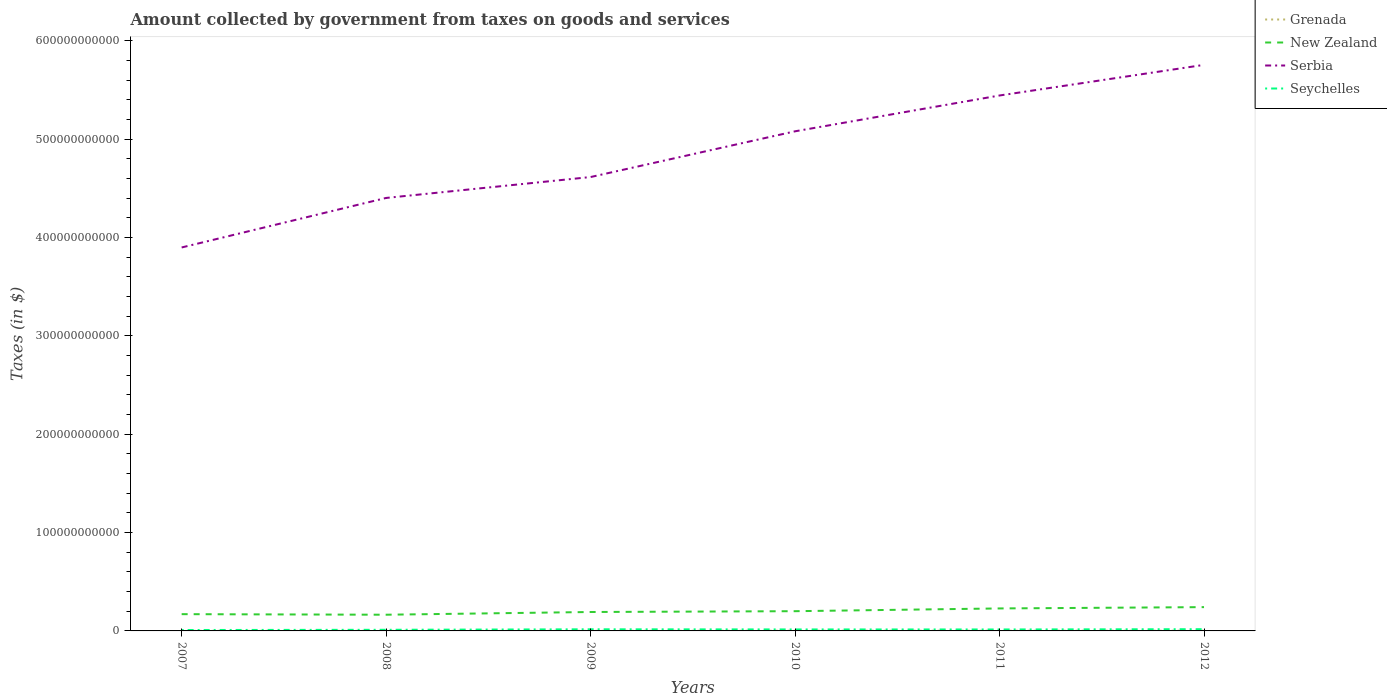How many different coloured lines are there?
Offer a very short reply. 4. Across all years, what is the maximum amount collected by government from taxes on goods and services in Seychelles?
Make the answer very short. 9.26e+08. In which year was the amount collected by government from taxes on goods and services in Grenada maximum?
Offer a terse response. 2007. What is the total amount collected by government from taxes on goods and services in Seychelles in the graph?
Provide a short and direct response. 2.78e+07. What is the difference between the highest and the second highest amount collected by government from taxes on goods and services in Seychelles?
Ensure brevity in your answer.  8.33e+08. What is the difference between the highest and the lowest amount collected by government from taxes on goods and services in Serbia?
Provide a short and direct response. 3. Is the amount collected by government from taxes on goods and services in Serbia strictly greater than the amount collected by government from taxes on goods and services in Grenada over the years?
Provide a short and direct response. No. What is the difference between two consecutive major ticks on the Y-axis?
Offer a terse response. 1.00e+11. Does the graph contain grids?
Offer a terse response. No. What is the title of the graph?
Offer a terse response. Amount collected by government from taxes on goods and services. What is the label or title of the X-axis?
Your answer should be very brief. Years. What is the label or title of the Y-axis?
Give a very brief answer. Taxes (in $). What is the Taxes (in $) in Grenada in 2007?
Keep it short and to the point. 7.13e+07. What is the Taxes (in $) in New Zealand in 2007?
Your answer should be compact. 1.70e+1. What is the Taxes (in $) in Serbia in 2007?
Keep it short and to the point. 3.90e+11. What is the Taxes (in $) of Seychelles in 2007?
Give a very brief answer. 9.26e+08. What is the Taxes (in $) of Grenada in 2008?
Your response must be concise. 7.87e+07. What is the Taxes (in $) in New Zealand in 2008?
Your response must be concise. 1.65e+1. What is the Taxes (in $) of Serbia in 2008?
Provide a short and direct response. 4.40e+11. What is the Taxes (in $) in Seychelles in 2008?
Provide a short and direct response. 1.15e+09. What is the Taxes (in $) of Grenada in 2009?
Provide a succinct answer. 7.60e+07. What is the Taxes (in $) in New Zealand in 2009?
Offer a terse response. 1.92e+1. What is the Taxes (in $) in Serbia in 2009?
Provide a short and direct response. 4.62e+11. What is the Taxes (in $) in Seychelles in 2009?
Your answer should be very brief. 1.66e+09. What is the Taxes (in $) in Grenada in 2010?
Your answer should be compact. 1.78e+08. What is the Taxes (in $) in New Zealand in 2010?
Your answer should be very brief. 2.01e+1. What is the Taxes (in $) of Serbia in 2010?
Provide a short and direct response. 5.08e+11. What is the Taxes (in $) in Seychelles in 2010?
Your answer should be very brief. 1.51e+09. What is the Taxes (in $) of Grenada in 2011?
Provide a succinct answer. 1.90e+08. What is the Taxes (in $) in New Zealand in 2011?
Keep it short and to the point. 2.29e+1. What is the Taxes (in $) of Serbia in 2011?
Make the answer very short. 5.45e+11. What is the Taxes (in $) in Seychelles in 2011?
Offer a very short reply. 1.48e+09. What is the Taxes (in $) in Grenada in 2012?
Make the answer very short. 1.90e+08. What is the Taxes (in $) in New Zealand in 2012?
Your response must be concise. 2.42e+1. What is the Taxes (in $) in Serbia in 2012?
Provide a succinct answer. 5.76e+11. What is the Taxes (in $) of Seychelles in 2012?
Offer a terse response. 1.76e+09. Across all years, what is the maximum Taxes (in $) of Grenada?
Your response must be concise. 1.90e+08. Across all years, what is the maximum Taxes (in $) in New Zealand?
Ensure brevity in your answer.  2.42e+1. Across all years, what is the maximum Taxes (in $) of Serbia?
Provide a short and direct response. 5.76e+11. Across all years, what is the maximum Taxes (in $) in Seychelles?
Offer a terse response. 1.76e+09. Across all years, what is the minimum Taxes (in $) of Grenada?
Make the answer very short. 7.13e+07. Across all years, what is the minimum Taxes (in $) in New Zealand?
Offer a very short reply. 1.65e+1. Across all years, what is the minimum Taxes (in $) in Serbia?
Offer a terse response. 3.90e+11. Across all years, what is the minimum Taxes (in $) of Seychelles?
Offer a very short reply. 9.26e+08. What is the total Taxes (in $) in Grenada in the graph?
Your answer should be very brief. 7.84e+08. What is the total Taxes (in $) of New Zealand in the graph?
Your response must be concise. 1.20e+11. What is the total Taxes (in $) in Serbia in the graph?
Make the answer very short. 2.92e+12. What is the total Taxes (in $) of Seychelles in the graph?
Your answer should be compact. 8.48e+09. What is the difference between the Taxes (in $) of Grenada in 2007 and that in 2008?
Offer a very short reply. -7.40e+06. What is the difference between the Taxes (in $) in New Zealand in 2007 and that in 2008?
Your answer should be very brief. 5.72e+08. What is the difference between the Taxes (in $) in Serbia in 2007 and that in 2008?
Make the answer very short. -5.04e+1. What is the difference between the Taxes (in $) in Seychelles in 2007 and that in 2008?
Ensure brevity in your answer.  -2.20e+08. What is the difference between the Taxes (in $) of Grenada in 2007 and that in 2009?
Offer a terse response. -4.70e+06. What is the difference between the Taxes (in $) of New Zealand in 2007 and that in 2009?
Your answer should be compact. -2.20e+09. What is the difference between the Taxes (in $) of Serbia in 2007 and that in 2009?
Keep it short and to the point. -7.16e+1. What is the difference between the Taxes (in $) in Seychelles in 2007 and that in 2009?
Offer a very short reply. -7.33e+08. What is the difference between the Taxes (in $) in Grenada in 2007 and that in 2010?
Provide a succinct answer. -1.07e+08. What is the difference between the Taxes (in $) of New Zealand in 2007 and that in 2010?
Give a very brief answer. -3.02e+09. What is the difference between the Taxes (in $) of Serbia in 2007 and that in 2010?
Make the answer very short. -1.18e+11. What is the difference between the Taxes (in $) of Seychelles in 2007 and that in 2010?
Make the answer very short. -5.84e+08. What is the difference between the Taxes (in $) of Grenada in 2007 and that in 2011?
Provide a short and direct response. -1.18e+08. What is the difference between the Taxes (in $) of New Zealand in 2007 and that in 2011?
Your answer should be compact. -5.82e+09. What is the difference between the Taxes (in $) in Serbia in 2007 and that in 2011?
Your answer should be compact. -1.55e+11. What is the difference between the Taxes (in $) in Seychelles in 2007 and that in 2011?
Your response must be concise. -5.56e+08. What is the difference between the Taxes (in $) of Grenada in 2007 and that in 2012?
Offer a very short reply. -1.18e+08. What is the difference between the Taxes (in $) of New Zealand in 2007 and that in 2012?
Make the answer very short. -7.15e+09. What is the difference between the Taxes (in $) of Serbia in 2007 and that in 2012?
Your answer should be compact. -1.86e+11. What is the difference between the Taxes (in $) of Seychelles in 2007 and that in 2012?
Provide a succinct answer. -8.33e+08. What is the difference between the Taxes (in $) in Grenada in 2008 and that in 2009?
Make the answer very short. 2.70e+06. What is the difference between the Taxes (in $) of New Zealand in 2008 and that in 2009?
Make the answer very short. -2.77e+09. What is the difference between the Taxes (in $) in Serbia in 2008 and that in 2009?
Keep it short and to the point. -2.13e+1. What is the difference between the Taxes (in $) of Seychelles in 2008 and that in 2009?
Offer a terse response. -5.13e+08. What is the difference between the Taxes (in $) of Grenada in 2008 and that in 2010?
Your answer should be very brief. -9.95e+07. What is the difference between the Taxes (in $) in New Zealand in 2008 and that in 2010?
Your response must be concise. -3.60e+09. What is the difference between the Taxes (in $) of Serbia in 2008 and that in 2010?
Your answer should be very brief. -6.78e+1. What is the difference between the Taxes (in $) of Seychelles in 2008 and that in 2010?
Give a very brief answer. -3.64e+08. What is the difference between the Taxes (in $) in Grenada in 2008 and that in 2011?
Your answer should be compact. -1.11e+08. What is the difference between the Taxes (in $) in New Zealand in 2008 and that in 2011?
Your answer should be very brief. -6.40e+09. What is the difference between the Taxes (in $) in Serbia in 2008 and that in 2011?
Your answer should be very brief. -1.04e+11. What is the difference between the Taxes (in $) in Seychelles in 2008 and that in 2011?
Offer a very short reply. -3.36e+08. What is the difference between the Taxes (in $) of Grenada in 2008 and that in 2012?
Your response must be concise. -1.11e+08. What is the difference between the Taxes (in $) in New Zealand in 2008 and that in 2012?
Offer a very short reply. -7.72e+09. What is the difference between the Taxes (in $) of Serbia in 2008 and that in 2012?
Ensure brevity in your answer.  -1.35e+11. What is the difference between the Taxes (in $) of Seychelles in 2008 and that in 2012?
Provide a short and direct response. -6.13e+08. What is the difference between the Taxes (in $) of Grenada in 2009 and that in 2010?
Offer a very short reply. -1.02e+08. What is the difference between the Taxes (in $) in New Zealand in 2009 and that in 2010?
Make the answer very short. -8.25e+08. What is the difference between the Taxes (in $) in Serbia in 2009 and that in 2010?
Provide a short and direct response. -4.65e+1. What is the difference between the Taxes (in $) of Seychelles in 2009 and that in 2010?
Your answer should be very brief. 1.49e+08. What is the difference between the Taxes (in $) in Grenada in 2009 and that in 2011?
Offer a terse response. -1.14e+08. What is the difference between the Taxes (in $) in New Zealand in 2009 and that in 2011?
Your answer should be compact. -3.63e+09. What is the difference between the Taxes (in $) of Serbia in 2009 and that in 2011?
Offer a very short reply. -8.29e+1. What is the difference between the Taxes (in $) of Seychelles in 2009 and that in 2011?
Ensure brevity in your answer.  1.77e+08. What is the difference between the Taxes (in $) in Grenada in 2009 and that in 2012?
Provide a short and direct response. -1.14e+08. What is the difference between the Taxes (in $) in New Zealand in 2009 and that in 2012?
Make the answer very short. -4.95e+09. What is the difference between the Taxes (in $) of Serbia in 2009 and that in 2012?
Ensure brevity in your answer.  -1.14e+11. What is the difference between the Taxes (in $) in Seychelles in 2009 and that in 2012?
Offer a terse response. -1.00e+08. What is the difference between the Taxes (in $) of Grenada in 2010 and that in 2011?
Give a very brief answer. -1.16e+07. What is the difference between the Taxes (in $) in New Zealand in 2010 and that in 2011?
Your answer should be very brief. -2.80e+09. What is the difference between the Taxes (in $) in Serbia in 2010 and that in 2011?
Give a very brief answer. -3.64e+1. What is the difference between the Taxes (in $) of Seychelles in 2010 and that in 2011?
Provide a short and direct response. 2.78e+07. What is the difference between the Taxes (in $) in Grenada in 2010 and that in 2012?
Your answer should be compact. -1.13e+07. What is the difference between the Taxes (in $) of New Zealand in 2010 and that in 2012?
Your answer should be very brief. -4.13e+09. What is the difference between the Taxes (in $) of Serbia in 2010 and that in 2012?
Make the answer very short. -6.76e+1. What is the difference between the Taxes (in $) of Seychelles in 2010 and that in 2012?
Offer a terse response. -2.49e+08. What is the difference between the Taxes (in $) in New Zealand in 2011 and that in 2012?
Offer a terse response. -1.33e+09. What is the difference between the Taxes (in $) of Serbia in 2011 and that in 2012?
Your answer should be very brief. -3.11e+1. What is the difference between the Taxes (in $) in Seychelles in 2011 and that in 2012?
Keep it short and to the point. -2.77e+08. What is the difference between the Taxes (in $) of Grenada in 2007 and the Taxes (in $) of New Zealand in 2008?
Provide a succinct answer. -1.64e+1. What is the difference between the Taxes (in $) in Grenada in 2007 and the Taxes (in $) in Serbia in 2008?
Your answer should be compact. -4.40e+11. What is the difference between the Taxes (in $) in Grenada in 2007 and the Taxes (in $) in Seychelles in 2008?
Provide a short and direct response. -1.08e+09. What is the difference between the Taxes (in $) in New Zealand in 2007 and the Taxes (in $) in Serbia in 2008?
Offer a very short reply. -4.23e+11. What is the difference between the Taxes (in $) of New Zealand in 2007 and the Taxes (in $) of Seychelles in 2008?
Provide a succinct answer. 1.59e+1. What is the difference between the Taxes (in $) in Serbia in 2007 and the Taxes (in $) in Seychelles in 2008?
Offer a terse response. 3.89e+11. What is the difference between the Taxes (in $) of Grenada in 2007 and the Taxes (in $) of New Zealand in 2009?
Ensure brevity in your answer.  -1.92e+1. What is the difference between the Taxes (in $) in Grenada in 2007 and the Taxes (in $) in Serbia in 2009?
Your answer should be compact. -4.62e+11. What is the difference between the Taxes (in $) of Grenada in 2007 and the Taxes (in $) of Seychelles in 2009?
Give a very brief answer. -1.59e+09. What is the difference between the Taxes (in $) in New Zealand in 2007 and the Taxes (in $) in Serbia in 2009?
Give a very brief answer. -4.45e+11. What is the difference between the Taxes (in $) in New Zealand in 2007 and the Taxes (in $) in Seychelles in 2009?
Provide a succinct answer. 1.54e+1. What is the difference between the Taxes (in $) in Serbia in 2007 and the Taxes (in $) in Seychelles in 2009?
Your answer should be very brief. 3.88e+11. What is the difference between the Taxes (in $) in Grenada in 2007 and the Taxes (in $) in New Zealand in 2010?
Offer a very short reply. -2.00e+1. What is the difference between the Taxes (in $) of Grenada in 2007 and the Taxes (in $) of Serbia in 2010?
Make the answer very short. -5.08e+11. What is the difference between the Taxes (in $) of Grenada in 2007 and the Taxes (in $) of Seychelles in 2010?
Offer a very short reply. -1.44e+09. What is the difference between the Taxes (in $) of New Zealand in 2007 and the Taxes (in $) of Serbia in 2010?
Your answer should be compact. -4.91e+11. What is the difference between the Taxes (in $) of New Zealand in 2007 and the Taxes (in $) of Seychelles in 2010?
Your answer should be very brief. 1.55e+1. What is the difference between the Taxes (in $) of Serbia in 2007 and the Taxes (in $) of Seychelles in 2010?
Ensure brevity in your answer.  3.88e+11. What is the difference between the Taxes (in $) in Grenada in 2007 and the Taxes (in $) in New Zealand in 2011?
Make the answer very short. -2.28e+1. What is the difference between the Taxes (in $) of Grenada in 2007 and the Taxes (in $) of Serbia in 2011?
Give a very brief answer. -5.44e+11. What is the difference between the Taxes (in $) in Grenada in 2007 and the Taxes (in $) in Seychelles in 2011?
Your answer should be compact. -1.41e+09. What is the difference between the Taxes (in $) of New Zealand in 2007 and the Taxes (in $) of Serbia in 2011?
Your answer should be very brief. -5.27e+11. What is the difference between the Taxes (in $) of New Zealand in 2007 and the Taxes (in $) of Seychelles in 2011?
Ensure brevity in your answer.  1.56e+1. What is the difference between the Taxes (in $) of Serbia in 2007 and the Taxes (in $) of Seychelles in 2011?
Keep it short and to the point. 3.88e+11. What is the difference between the Taxes (in $) of Grenada in 2007 and the Taxes (in $) of New Zealand in 2012?
Provide a short and direct response. -2.41e+1. What is the difference between the Taxes (in $) of Grenada in 2007 and the Taxes (in $) of Serbia in 2012?
Offer a terse response. -5.76e+11. What is the difference between the Taxes (in $) of Grenada in 2007 and the Taxes (in $) of Seychelles in 2012?
Offer a very short reply. -1.69e+09. What is the difference between the Taxes (in $) in New Zealand in 2007 and the Taxes (in $) in Serbia in 2012?
Ensure brevity in your answer.  -5.59e+11. What is the difference between the Taxes (in $) of New Zealand in 2007 and the Taxes (in $) of Seychelles in 2012?
Your answer should be very brief. 1.53e+1. What is the difference between the Taxes (in $) in Serbia in 2007 and the Taxes (in $) in Seychelles in 2012?
Your answer should be compact. 3.88e+11. What is the difference between the Taxes (in $) in Grenada in 2008 and the Taxes (in $) in New Zealand in 2009?
Offer a very short reply. -1.92e+1. What is the difference between the Taxes (in $) of Grenada in 2008 and the Taxes (in $) of Serbia in 2009?
Your answer should be compact. -4.62e+11. What is the difference between the Taxes (in $) of Grenada in 2008 and the Taxes (in $) of Seychelles in 2009?
Keep it short and to the point. -1.58e+09. What is the difference between the Taxes (in $) in New Zealand in 2008 and the Taxes (in $) in Serbia in 2009?
Offer a terse response. -4.45e+11. What is the difference between the Taxes (in $) in New Zealand in 2008 and the Taxes (in $) in Seychelles in 2009?
Your answer should be compact. 1.48e+1. What is the difference between the Taxes (in $) of Serbia in 2008 and the Taxes (in $) of Seychelles in 2009?
Your response must be concise. 4.39e+11. What is the difference between the Taxes (in $) of Grenada in 2008 and the Taxes (in $) of New Zealand in 2010?
Your answer should be very brief. -2.00e+1. What is the difference between the Taxes (in $) in Grenada in 2008 and the Taxes (in $) in Serbia in 2010?
Give a very brief answer. -5.08e+11. What is the difference between the Taxes (in $) in Grenada in 2008 and the Taxes (in $) in Seychelles in 2010?
Give a very brief answer. -1.43e+09. What is the difference between the Taxes (in $) of New Zealand in 2008 and the Taxes (in $) of Serbia in 2010?
Provide a succinct answer. -4.92e+11. What is the difference between the Taxes (in $) of New Zealand in 2008 and the Taxes (in $) of Seychelles in 2010?
Your response must be concise. 1.50e+1. What is the difference between the Taxes (in $) of Serbia in 2008 and the Taxes (in $) of Seychelles in 2010?
Offer a terse response. 4.39e+11. What is the difference between the Taxes (in $) in Grenada in 2008 and the Taxes (in $) in New Zealand in 2011?
Your answer should be compact. -2.28e+1. What is the difference between the Taxes (in $) of Grenada in 2008 and the Taxes (in $) of Serbia in 2011?
Offer a terse response. -5.44e+11. What is the difference between the Taxes (in $) of Grenada in 2008 and the Taxes (in $) of Seychelles in 2011?
Ensure brevity in your answer.  -1.40e+09. What is the difference between the Taxes (in $) in New Zealand in 2008 and the Taxes (in $) in Serbia in 2011?
Offer a very short reply. -5.28e+11. What is the difference between the Taxes (in $) in New Zealand in 2008 and the Taxes (in $) in Seychelles in 2011?
Keep it short and to the point. 1.50e+1. What is the difference between the Taxes (in $) of Serbia in 2008 and the Taxes (in $) of Seychelles in 2011?
Keep it short and to the point. 4.39e+11. What is the difference between the Taxes (in $) of Grenada in 2008 and the Taxes (in $) of New Zealand in 2012?
Offer a terse response. -2.41e+1. What is the difference between the Taxes (in $) of Grenada in 2008 and the Taxes (in $) of Serbia in 2012?
Provide a succinct answer. -5.76e+11. What is the difference between the Taxes (in $) of Grenada in 2008 and the Taxes (in $) of Seychelles in 2012?
Offer a very short reply. -1.68e+09. What is the difference between the Taxes (in $) of New Zealand in 2008 and the Taxes (in $) of Serbia in 2012?
Provide a short and direct response. -5.59e+11. What is the difference between the Taxes (in $) in New Zealand in 2008 and the Taxes (in $) in Seychelles in 2012?
Offer a terse response. 1.47e+1. What is the difference between the Taxes (in $) in Serbia in 2008 and the Taxes (in $) in Seychelles in 2012?
Offer a very short reply. 4.39e+11. What is the difference between the Taxes (in $) in Grenada in 2009 and the Taxes (in $) in New Zealand in 2010?
Ensure brevity in your answer.  -2.00e+1. What is the difference between the Taxes (in $) of Grenada in 2009 and the Taxes (in $) of Serbia in 2010?
Provide a succinct answer. -5.08e+11. What is the difference between the Taxes (in $) in Grenada in 2009 and the Taxes (in $) in Seychelles in 2010?
Provide a succinct answer. -1.43e+09. What is the difference between the Taxes (in $) of New Zealand in 2009 and the Taxes (in $) of Serbia in 2010?
Ensure brevity in your answer.  -4.89e+11. What is the difference between the Taxes (in $) in New Zealand in 2009 and the Taxes (in $) in Seychelles in 2010?
Make the answer very short. 1.77e+1. What is the difference between the Taxes (in $) in Serbia in 2009 and the Taxes (in $) in Seychelles in 2010?
Your answer should be compact. 4.60e+11. What is the difference between the Taxes (in $) in Grenada in 2009 and the Taxes (in $) in New Zealand in 2011?
Your response must be concise. -2.28e+1. What is the difference between the Taxes (in $) in Grenada in 2009 and the Taxes (in $) in Serbia in 2011?
Make the answer very short. -5.44e+11. What is the difference between the Taxes (in $) in Grenada in 2009 and the Taxes (in $) in Seychelles in 2011?
Provide a short and direct response. -1.41e+09. What is the difference between the Taxes (in $) of New Zealand in 2009 and the Taxes (in $) of Serbia in 2011?
Your answer should be very brief. -5.25e+11. What is the difference between the Taxes (in $) of New Zealand in 2009 and the Taxes (in $) of Seychelles in 2011?
Your answer should be compact. 1.78e+1. What is the difference between the Taxes (in $) of Serbia in 2009 and the Taxes (in $) of Seychelles in 2011?
Provide a short and direct response. 4.60e+11. What is the difference between the Taxes (in $) of Grenada in 2009 and the Taxes (in $) of New Zealand in 2012?
Ensure brevity in your answer.  -2.41e+1. What is the difference between the Taxes (in $) of Grenada in 2009 and the Taxes (in $) of Serbia in 2012?
Ensure brevity in your answer.  -5.76e+11. What is the difference between the Taxes (in $) in Grenada in 2009 and the Taxes (in $) in Seychelles in 2012?
Offer a terse response. -1.68e+09. What is the difference between the Taxes (in $) in New Zealand in 2009 and the Taxes (in $) in Serbia in 2012?
Your answer should be very brief. -5.56e+11. What is the difference between the Taxes (in $) of New Zealand in 2009 and the Taxes (in $) of Seychelles in 2012?
Give a very brief answer. 1.75e+1. What is the difference between the Taxes (in $) of Serbia in 2009 and the Taxes (in $) of Seychelles in 2012?
Provide a short and direct response. 4.60e+11. What is the difference between the Taxes (in $) of Grenada in 2010 and the Taxes (in $) of New Zealand in 2011?
Keep it short and to the point. -2.27e+1. What is the difference between the Taxes (in $) in Grenada in 2010 and the Taxes (in $) in Serbia in 2011?
Your answer should be compact. -5.44e+11. What is the difference between the Taxes (in $) in Grenada in 2010 and the Taxes (in $) in Seychelles in 2011?
Offer a terse response. -1.30e+09. What is the difference between the Taxes (in $) in New Zealand in 2010 and the Taxes (in $) in Serbia in 2011?
Your answer should be compact. -5.24e+11. What is the difference between the Taxes (in $) in New Zealand in 2010 and the Taxes (in $) in Seychelles in 2011?
Your answer should be compact. 1.86e+1. What is the difference between the Taxes (in $) in Serbia in 2010 and the Taxes (in $) in Seychelles in 2011?
Provide a short and direct response. 5.07e+11. What is the difference between the Taxes (in $) in Grenada in 2010 and the Taxes (in $) in New Zealand in 2012?
Offer a very short reply. -2.40e+1. What is the difference between the Taxes (in $) of Grenada in 2010 and the Taxes (in $) of Serbia in 2012?
Provide a succinct answer. -5.75e+11. What is the difference between the Taxes (in $) of Grenada in 2010 and the Taxes (in $) of Seychelles in 2012?
Your response must be concise. -1.58e+09. What is the difference between the Taxes (in $) of New Zealand in 2010 and the Taxes (in $) of Serbia in 2012?
Give a very brief answer. -5.56e+11. What is the difference between the Taxes (in $) of New Zealand in 2010 and the Taxes (in $) of Seychelles in 2012?
Offer a very short reply. 1.83e+1. What is the difference between the Taxes (in $) in Serbia in 2010 and the Taxes (in $) in Seychelles in 2012?
Your answer should be compact. 5.06e+11. What is the difference between the Taxes (in $) of Grenada in 2011 and the Taxes (in $) of New Zealand in 2012?
Your answer should be compact. -2.40e+1. What is the difference between the Taxes (in $) of Grenada in 2011 and the Taxes (in $) of Serbia in 2012?
Keep it short and to the point. -5.75e+11. What is the difference between the Taxes (in $) of Grenada in 2011 and the Taxes (in $) of Seychelles in 2012?
Provide a succinct answer. -1.57e+09. What is the difference between the Taxes (in $) in New Zealand in 2011 and the Taxes (in $) in Serbia in 2012?
Ensure brevity in your answer.  -5.53e+11. What is the difference between the Taxes (in $) in New Zealand in 2011 and the Taxes (in $) in Seychelles in 2012?
Provide a succinct answer. 2.11e+1. What is the difference between the Taxes (in $) in Serbia in 2011 and the Taxes (in $) in Seychelles in 2012?
Make the answer very short. 5.43e+11. What is the average Taxes (in $) in Grenada per year?
Offer a very short reply. 1.31e+08. What is the average Taxes (in $) in New Zealand per year?
Your response must be concise. 2.00e+1. What is the average Taxes (in $) of Serbia per year?
Offer a terse response. 4.87e+11. What is the average Taxes (in $) of Seychelles per year?
Your response must be concise. 1.41e+09. In the year 2007, what is the difference between the Taxes (in $) of Grenada and Taxes (in $) of New Zealand?
Keep it short and to the point. -1.70e+1. In the year 2007, what is the difference between the Taxes (in $) of Grenada and Taxes (in $) of Serbia?
Provide a succinct answer. -3.90e+11. In the year 2007, what is the difference between the Taxes (in $) of Grenada and Taxes (in $) of Seychelles?
Offer a very short reply. -8.55e+08. In the year 2007, what is the difference between the Taxes (in $) in New Zealand and Taxes (in $) in Serbia?
Keep it short and to the point. -3.73e+11. In the year 2007, what is the difference between the Taxes (in $) in New Zealand and Taxes (in $) in Seychelles?
Make the answer very short. 1.61e+1. In the year 2007, what is the difference between the Taxes (in $) in Serbia and Taxes (in $) in Seychelles?
Ensure brevity in your answer.  3.89e+11. In the year 2008, what is the difference between the Taxes (in $) of Grenada and Taxes (in $) of New Zealand?
Offer a very short reply. -1.64e+1. In the year 2008, what is the difference between the Taxes (in $) in Grenada and Taxes (in $) in Serbia?
Provide a short and direct response. -4.40e+11. In the year 2008, what is the difference between the Taxes (in $) of Grenada and Taxes (in $) of Seychelles?
Your answer should be compact. -1.07e+09. In the year 2008, what is the difference between the Taxes (in $) of New Zealand and Taxes (in $) of Serbia?
Provide a succinct answer. -4.24e+11. In the year 2008, what is the difference between the Taxes (in $) in New Zealand and Taxes (in $) in Seychelles?
Ensure brevity in your answer.  1.53e+1. In the year 2008, what is the difference between the Taxes (in $) of Serbia and Taxes (in $) of Seychelles?
Keep it short and to the point. 4.39e+11. In the year 2009, what is the difference between the Taxes (in $) of Grenada and Taxes (in $) of New Zealand?
Your answer should be compact. -1.92e+1. In the year 2009, what is the difference between the Taxes (in $) of Grenada and Taxes (in $) of Serbia?
Your answer should be compact. -4.62e+11. In the year 2009, what is the difference between the Taxes (in $) of Grenada and Taxes (in $) of Seychelles?
Ensure brevity in your answer.  -1.58e+09. In the year 2009, what is the difference between the Taxes (in $) of New Zealand and Taxes (in $) of Serbia?
Your answer should be very brief. -4.42e+11. In the year 2009, what is the difference between the Taxes (in $) of New Zealand and Taxes (in $) of Seychelles?
Offer a very short reply. 1.76e+1. In the year 2009, what is the difference between the Taxes (in $) of Serbia and Taxes (in $) of Seychelles?
Your response must be concise. 4.60e+11. In the year 2010, what is the difference between the Taxes (in $) in Grenada and Taxes (in $) in New Zealand?
Make the answer very short. -1.99e+1. In the year 2010, what is the difference between the Taxes (in $) in Grenada and Taxes (in $) in Serbia?
Ensure brevity in your answer.  -5.08e+11. In the year 2010, what is the difference between the Taxes (in $) of Grenada and Taxes (in $) of Seychelles?
Your response must be concise. -1.33e+09. In the year 2010, what is the difference between the Taxes (in $) of New Zealand and Taxes (in $) of Serbia?
Give a very brief answer. -4.88e+11. In the year 2010, what is the difference between the Taxes (in $) of New Zealand and Taxes (in $) of Seychelles?
Your answer should be compact. 1.86e+1. In the year 2010, what is the difference between the Taxes (in $) in Serbia and Taxes (in $) in Seychelles?
Provide a succinct answer. 5.07e+11. In the year 2011, what is the difference between the Taxes (in $) of Grenada and Taxes (in $) of New Zealand?
Keep it short and to the point. -2.27e+1. In the year 2011, what is the difference between the Taxes (in $) in Grenada and Taxes (in $) in Serbia?
Your answer should be compact. -5.44e+11. In the year 2011, what is the difference between the Taxes (in $) of Grenada and Taxes (in $) of Seychelles?
Keep it short and to the point. -1.29e+09. In the year 2011, what is the difference between the Taxes (in $) in New Zealand and Taxes (in $) in Serbia?
Ensure brevity in your answer.  -5.22e+11. In the year 2011, what is the difference between the Taxes (in $) of New Zealand and Taxes (in $) of Seychelles?
Your answer should be compact. 2.14e+1. In the year 2011, what is the difference between the Taxes (in $) of Serbia and Taxes (in $) of Seychelles?
Offer a very short reply. 5.43e+11. In the year 2012, what is the difference between the Taxes (in $) in Grenada and Taxes (in $) in New Zealand?
Provide a short and direct response. -2.40e+1. In the year 2012, what is the difference between the Taxes (in $) in Grenada and Taxes (in $) in Serbia?
Ensure brevity in your answer.  -5.75e+11. In the year 2012, what is the difference between the Taxes (in $) of Grenada and Taxes (in $) of Seychelles?
Offer a very short reply. -1.57e+09. In the year 2012, what is the difference between the Taxes (in $) in New Zealand and Taxes (in $) in Serbia?
Give a very brief answer. -5.51e+11. In the year 2012, what is the difference between the Taxes (in $) of New Zealand and Taxes (in $) of Seychelles?
Provide a short and direct response. 2.24e+1. In the year 2012, what is the difference between the Taxes (in $) in Serbia and Taxes (in $) in Seychelles?
Your answer should be very brief. 5.74e+11. What is the ratio of the Taxes (in $) in Grenada in 2007 to that in 2008?
Offer a very short reply. 0.91. What is the ratio of the Taxes (in $) of New Zealand in 2007 to that in 2008?
Make the answer very short. 1.03. What is the ratio of the Taxes (in $) in Serbia in 2007 to that in 2008?
Make the answer very short. 0.89. What is the ratio of the Taxes (in $) of Seychelles in 2007 to that in 2008?
Make the answer very short. 0.81. What is the ratio of the Taxes (in $) in Grenada in 2007 to that in 2009?
Offer a terse response. 0.94. What is the ratio of the Taxes (in $) of New Zealand in 2007 to that in 2009?
Your response must be concise. 0.89. What is the ratio of the Taxes (in $) in Serbia in 2007 to that in 2009?
Provide a succinct answer. 0.84. What is the ratio of the Taxes (in $) in Seychelles in 2007 to that in 2009?
Your answer should be compact. 0.56. What is the ratio of the Taxes (in $) of Grenada in 2007 to that in 2010?
Keep it short and to the point. 0.4. What is the ratio of the Taxes (in $) of New Zealand in 2007 to that in 2010?
Provide a succinct answer. 0.85. What is the ratio of the Taxes (in $) in Serbia in 2007 to that in 2010?
Make the answer very short. 0.77. What is the ratio of the Taxes (in $) in Seychelles in 2007 to that in 2010?
Your response must be concise. 0.61. What is the ratio of the Taxes (in $) of Grenada in 2007 to that in 2011?
Provide a short and direct response. 0.38. What is the ratio of the Taxes (in $) of New Zealand in 2007 to that in 2011?
Offer a terse response. 0.75. What is the ratio of the Taxes (in $) of Serbia in 2007 to that in 2011?
Your response must be concise. 0.72. What is the ratio of the Taxes (in $) in Seychelles in 2007 to that in 2011?
Your answer should be very brief. 0.62. What is the ratio of the Taxes (in $) in Grenada in 2007 to that in 2012?
Offer a very short reply. 0.38. What is the ratio of the Taxes (in $) of New Zealand in 2007 to that in 2012?
Your response must be concise. 0.7. What is the ratio of the Taxes (in $) of Serbia in 2007 to that in 2012?
Give a very brief answer. 0.68. What is the ratio of the Taxes (in $) of Seychelles in 2007 to that in 2012?
Ensure brevity in your answer.  0.53. What is the ratio of the Taxes (in $) in Grenada in 2008 to that in 2009?
Offer a very short reply. 1.04. What is the ratio of the Taxes (in $) of New Zealand in 2008 to that in 2009?
Provide a succinct answer. 0.86. What is the ratio of the Taxes (in $) of Serbia in 2008 to that in 2009?
Ensure brevity in your answer.  0.95. What is the ratio of the Taxes (in $) of Seychelles in 2008 to that in 2009?
Your response must be concise. 0.69. What is the ratio of the Taxes (in $) of Grenada in 2008 to that in 2010?
Provide a succinct answer. 0.44. What is the ratio of the Taxes (in $) in New Zealand in 2008 to that in 2010?
Ensure brevity in your answer.  0.82. What is the ratio of the Taxes (in $) of Serbia in 2008 to that in 2010?
Provide a succinct answer. 0.87. What is the ratio of the Taxes (in $) of Seychelles in 2008 to that in 2010?
Your answer should be very brief. 0.76. What is the ratio of the Taxes (in $) of Grenada in 2008 to that in 2011?
Keep it short and to the point. 0.41. What is the ratio of the Taxes (in $) of New Zealand in 2008 to that in 2011?
Your answer should be compact. 0.72. What is the ratio of the Taxes (in $) in Serbia in 2008 to that in 2011?
Offer a very short reply. 0.81. What is the ratio of the Taxes (in $) in Seychelles in 2008 to that in 2011?
Your response must be concise. 0.77. What is the ratio of the Taxes (in $) of Grenada in 2008 to that in 2012?
Your response must be concise. 0.42. What is the ratio of the Taxes (in $) of New Zealand in 2008 to that in 2012?
Provide a succinct answer. 0.68. What is the ratio of the Taxes (in $) of Serbia in 2008 to that in 2012?
Provide a short and direct response. 0.76. What is the ratio of the Taxes (in $) in Seychelles in 2008 to that in 2012?
Your answer should be compact. 0.65. What is the ratio of the Taxes (in $) in Grenada in 2009 to that in 2010?
Make the answer very short. 0.43. What is the ratio of the Taxes (in $) of New Zealand in 2009 to that in 2010?
Offer a terse response. 0.96. What is the ratio of the Taxes (in $) of Serbia in 2009 to that in 2010?
Your answer should be compact. 0.91. What is the ratio of the Taxes (in $) in Seychelles in 2009 to that in 2010?
Ensure brevity in your answer.  1.1. What is the ratio of the Taxes (in $) of Grenada in 2009 to that in 2011?
Give a very brief answer. 0.4. What is the ratio of the Taxes (in $) in New Zealand in 2009 to that in 2011?
Make the answer very short. 0.84. What is the ratio of the Taxes (in $) of Serbia in 2009 to that in 2011?
Provide a short and direct response. 0.85. What is the ratio of the Taxes (in $) of Seychelles in 2009 to that in 2011?
Offer a terse response. 1.12. What is the ratio of the Taxes (in $) in Grenada in 2009 to that in 2012?
Your answer should be very brief. 0.4. What is the ratio of the Taxes (in $) of New Zealand in 2009 to that in 2012?
Provide a succinct answer. 0.8. What is the ratio of the Taxes (in $) in Serbia in 2009 to that in 2012?
Provide a short and direct response. 0.8. What is the ratio of the Taxes (in $) in Seychelles in 2009 to that in 2012?
Provide a short and direct response. 0.94. What is the ratio of the Taxes (in $) of Grenada in 2010 to that in 2011?
Offer a terse response. 0.94. What is the ratio of the Taxes (in $) in New Zealand in 2010 to that in 2011?
Keep it short and to the point. 0.88. What is the ratio of the Taxes (in $) in Serbia in 2010 to that in 2011?
Ensure brevity in your answer.  0.93. What is the ratio of the Taxes (in $) in Seychelles in 2010 to that in 2011?
Your answer should be compact. 1.02. What is the ratio of the Taxes (in $) of Grenada in 2010 to that in 2012?
Keep it short and to the point. 0.94. What is the ratio of the Taxes (in $) of New Zealand in 2010 to that in 2012?
Make the answer very short. 0.83. What is the ratio of the Taxes (in $) of Serbia in 2010 to that in 2012?
Offer a very short reply. 0.88. What is the ratio of the Taxes (in $) in Seychelles in 2010 to that in 2012?
Offer a terse response. 0.86. What is the ratio of the Taxes (in $) of New Zealand in 2011 to that in 2012?
Your answer should be compact. 0.95. What is the ratio of the Taxes (in $) of Serbia in 2011 to that in 2012?
Offer a terse response. 0.95. What is the ratio of the Taxes (in $) in Seychelles in 2011 to that in 2012?
Your answer should be compact. 0.84. What is the difference between the highest and the second highest Taxes (in $) of Grenada?
Offer a terse response. 3.00e+05. What is the difference between the highest and the second highest Taxes (in $) of New Zealand?
Keep it short and to the point. 1.33e+09. What is the difference between the highest and the second highest Taxes (in $) of Serbia?
Your answer should be compact. 3.11e+1. What is the difference between the highest and the second highest Taxes (in $) in Seychelles?
Ensure brevity in your answer.  1.00e+08. What is the difference between the highest and the lowest Taxes (in $) of Grenada?
Give a very brief answer. 1.18e+08. What is the difference between the highest and the lowest Taxes (in $) in New Zealand?
Your answer should be compact. 7.72e+09. What is the difference between the highest and the lowest Taxes (in $) in Serbia?
Make the answer very short. 1.86e+11. What is the difference between the highest and the lowest Taxes (in $) in Seychelles?
Offer a very short reply. 8.33e+08. 